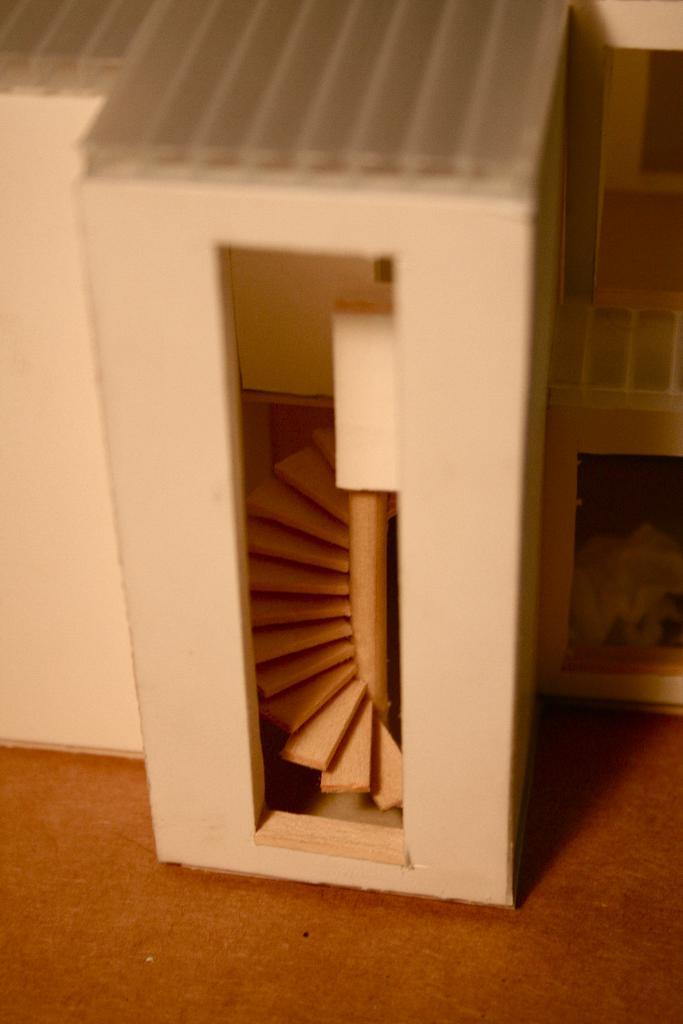What is the main subject of the image? The main subject of the image is a craft. What material is the craft made of? The craft is made up of wood. What type of corn is being used to make the cushion in the image? There is no corn or cushion present in the image; it features a wooden craft. 